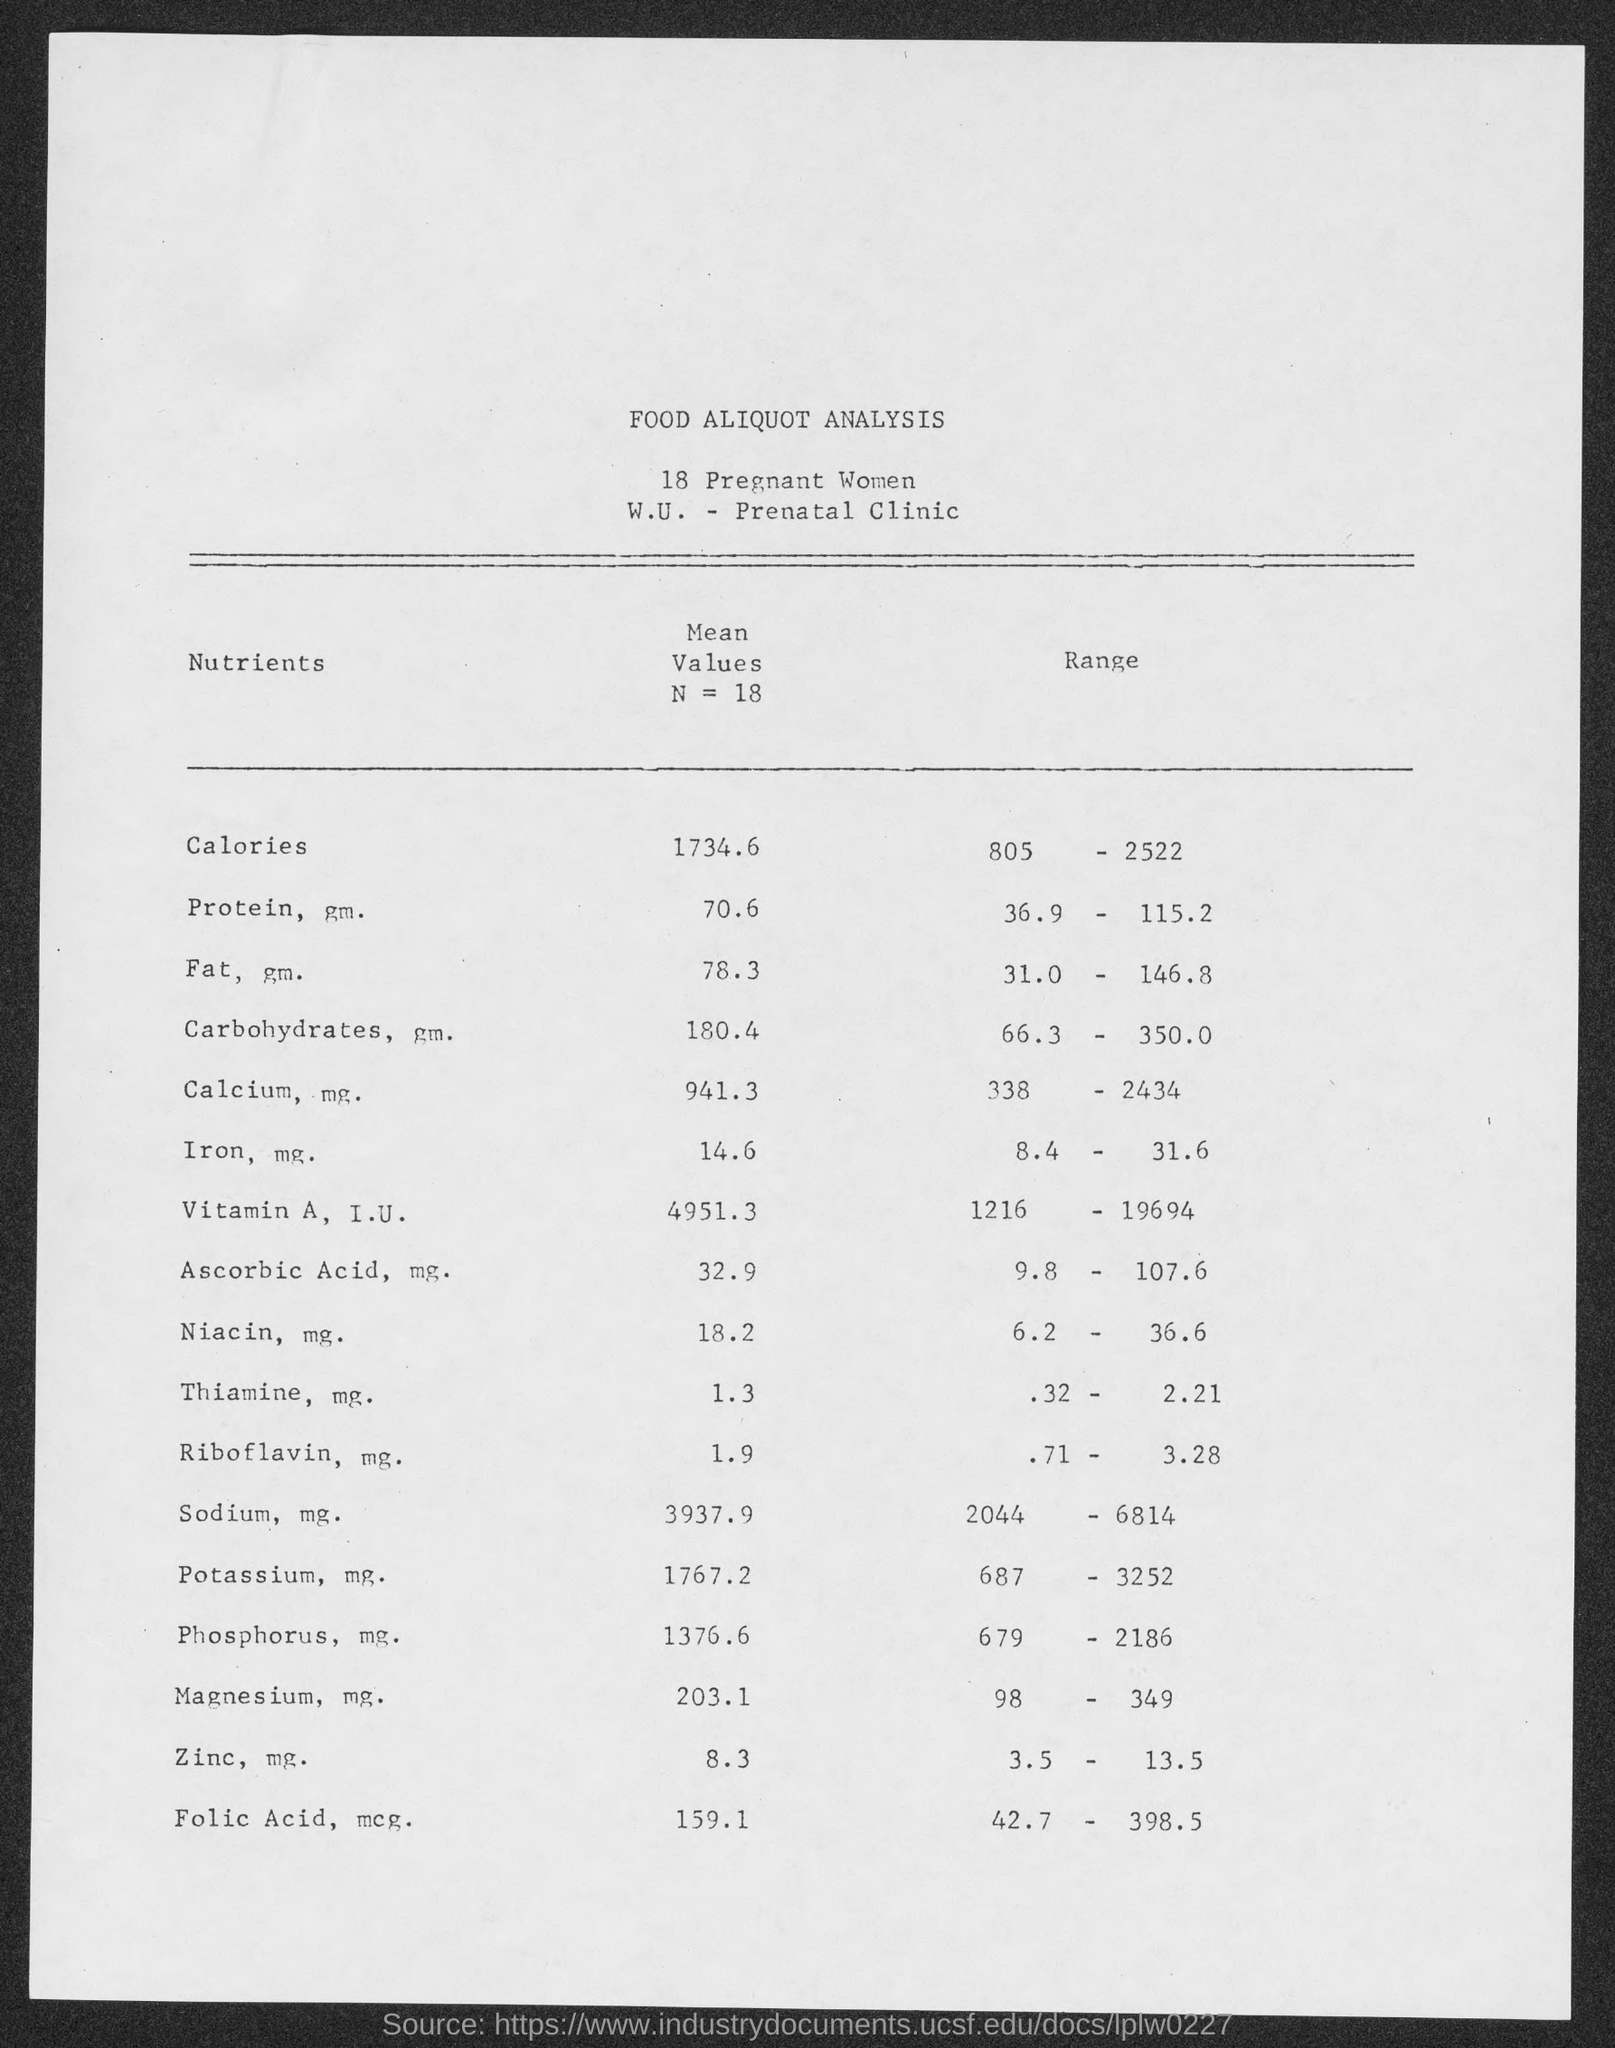What is the mean values n = 18 for calories ?
Provide a short and direct response. 1734.6. What is the mean values n = 18 for protein, gm.?
Your response must be concise. 70.6. What is the mean values n = 18 for fat,gm.?
Make the answer very short. 78.3. What is the mean values n = 18 for carbohydrates,gm.?
Ensure brevity in your answer.  180.4. What is the mean values n = 18 for calcium, mg ?
Offer a terse response. 941.3. What is the mean values n = 18 for  iron, mg?
Your answer should be very brief. 14.6. What is the mean values n = 18 for ascorbic acid, mg?
Your response must be concise. 32.9. What is the mean values n = 18 for niacin, mg.?
Ensure brevity in your answer.  18.2. What is the mean values n = 18 for  thiamine, mg.?
Ensure brevity in your answer.  1.3. What is the mean values n = 18 for riboflavin,mg.?
Your response must be concise. 1.9. 